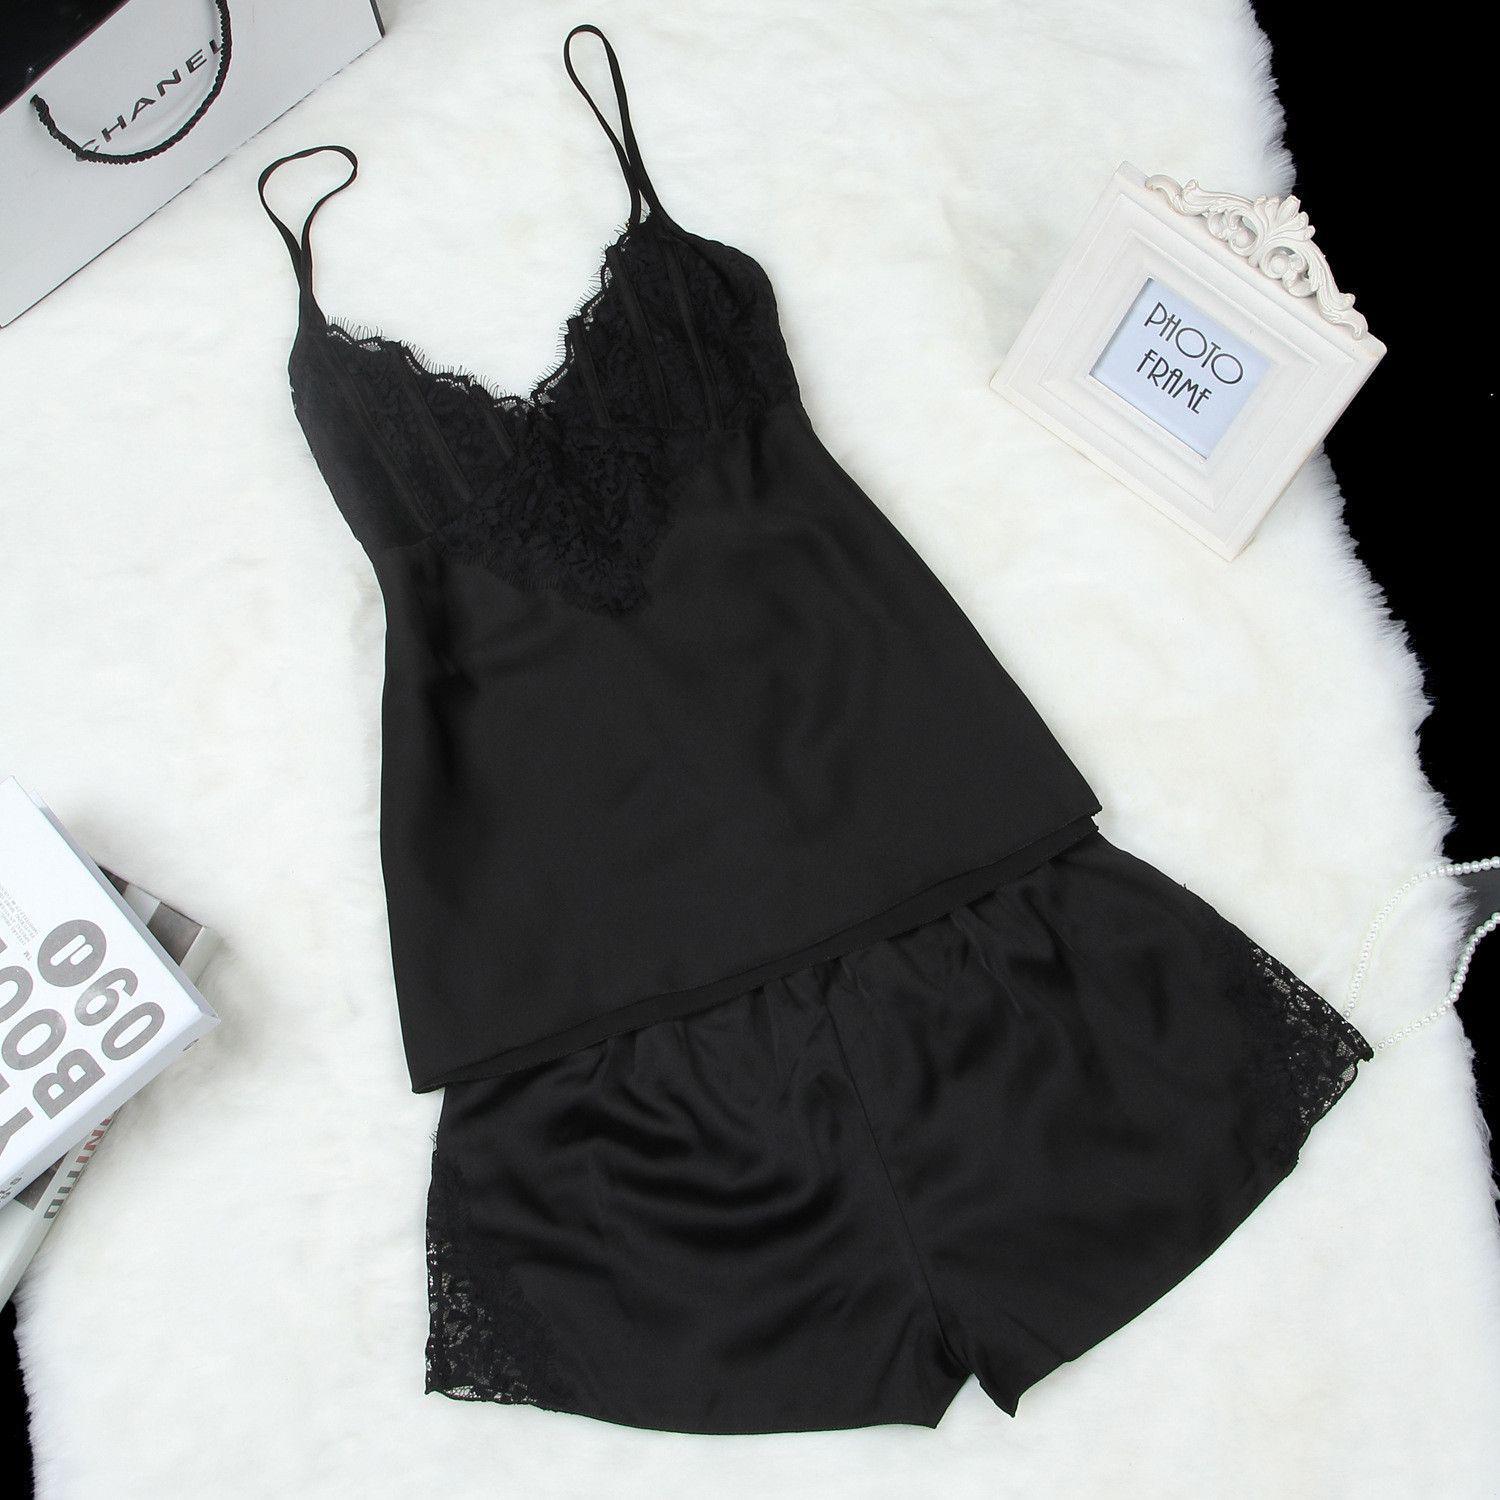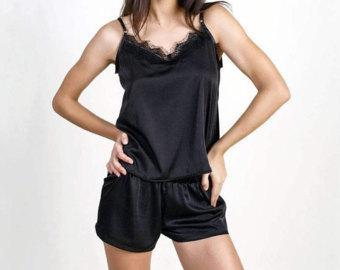The first image is the image on the left, the second image is the image on the right. Given the left and right images, does the statement "One image contains a women wearing black sleep attire." hold true? Answer yes or no. Yes. The first image is the image on the left, the second image is the image on the right. Examine the images to the left and right. Is the description "In one image, a woman is wearing a black pajama set that is comprised of shorts and a camisole top" accurate? Answer yes or no. Yes. 